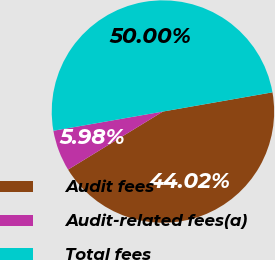<chart> <loc_0><loc_0><loc_500><loc_500><pie_chart><fcel>Audit fees<fcel>Audit-related fees(a)<fcel>Total fees<nl><fcel>44.02%<fcel>5.98%<fcel>50.0%<nl></chart> 